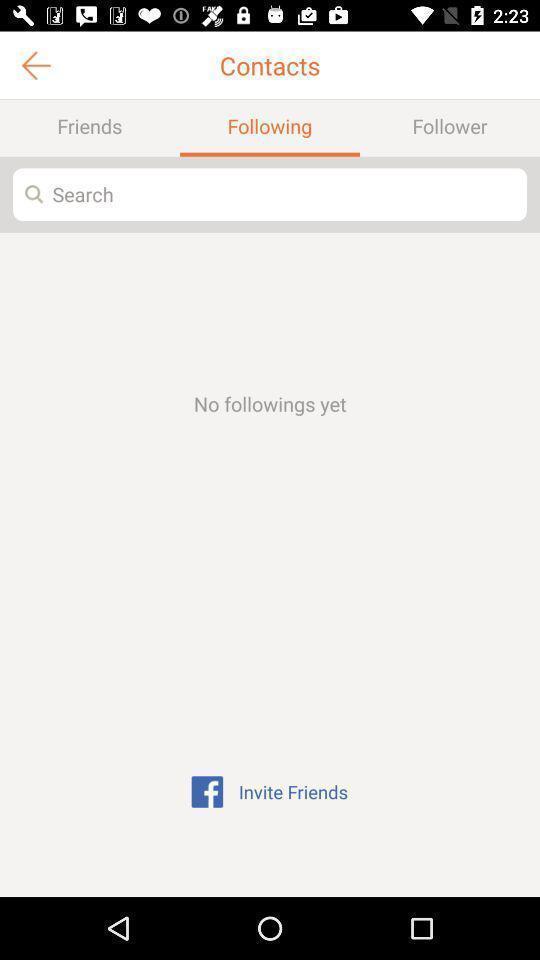Summarize the information in this screenshot. Screen displaying the following page. 